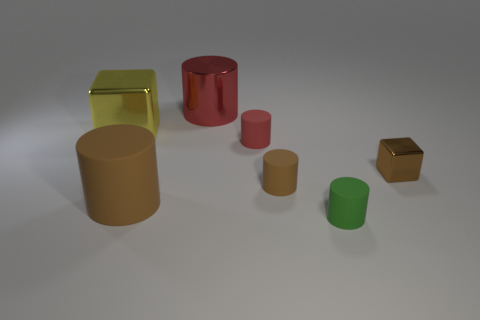Subtract all blue cubes. How many red cylinders are left? 2 Subtract all green cylinders. How many cylinders are left? 4 Subtract 1 cylinders. How many cylinders are left? 4 Subtract all green cylinders. How many cylinders are left? 4 Add 1 small brown rubber things. How many objects exist? 8 Subtract all cylinders. How many objects are left? 2 Subtract all purple cylinders. Subtract all green blocks. How many cylinders are left? 5 Add 3 tiny red cylinders. How many tiny red cylinders are left? 4 Add 7 metallic cylinders. How many metallic cylinders exist? 8 Subtract 0 blue blocks. How many objects are left? 7 